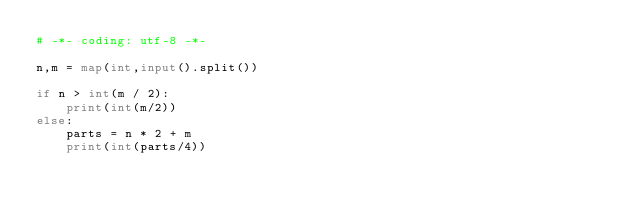Convert code to text. <code><loc_0><loc_0><loc_500><loc_500><_Python_># -*- coding: utf-8 -*-

n,m = map(int,input().split())

if n > int(m / 2):
    print(int(m/2))
else:
    parts = n * 2 + m
    print(int(parts/4))
</code> 